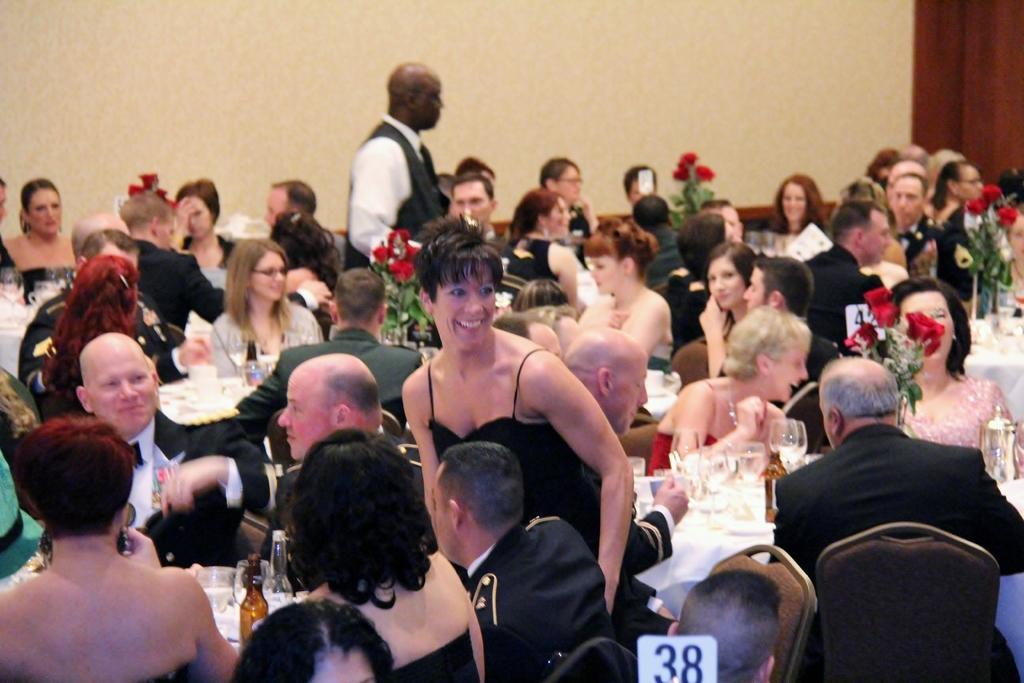In one or two sentences, can you explain what this image depicts? This image is taken indoors. In the background there is a wall. In the middle of the image many people are sitting on the chairs and there are many tables with tablecloths and many things on them and there are a few flower vases on the tables. A man and a woman are standing on the floor. 